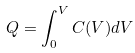<formula> <loc_0><loc_0><loc_500><loc_500>Q = \int _ { 0 } ^ { V } C ( V ) d V</formula> 